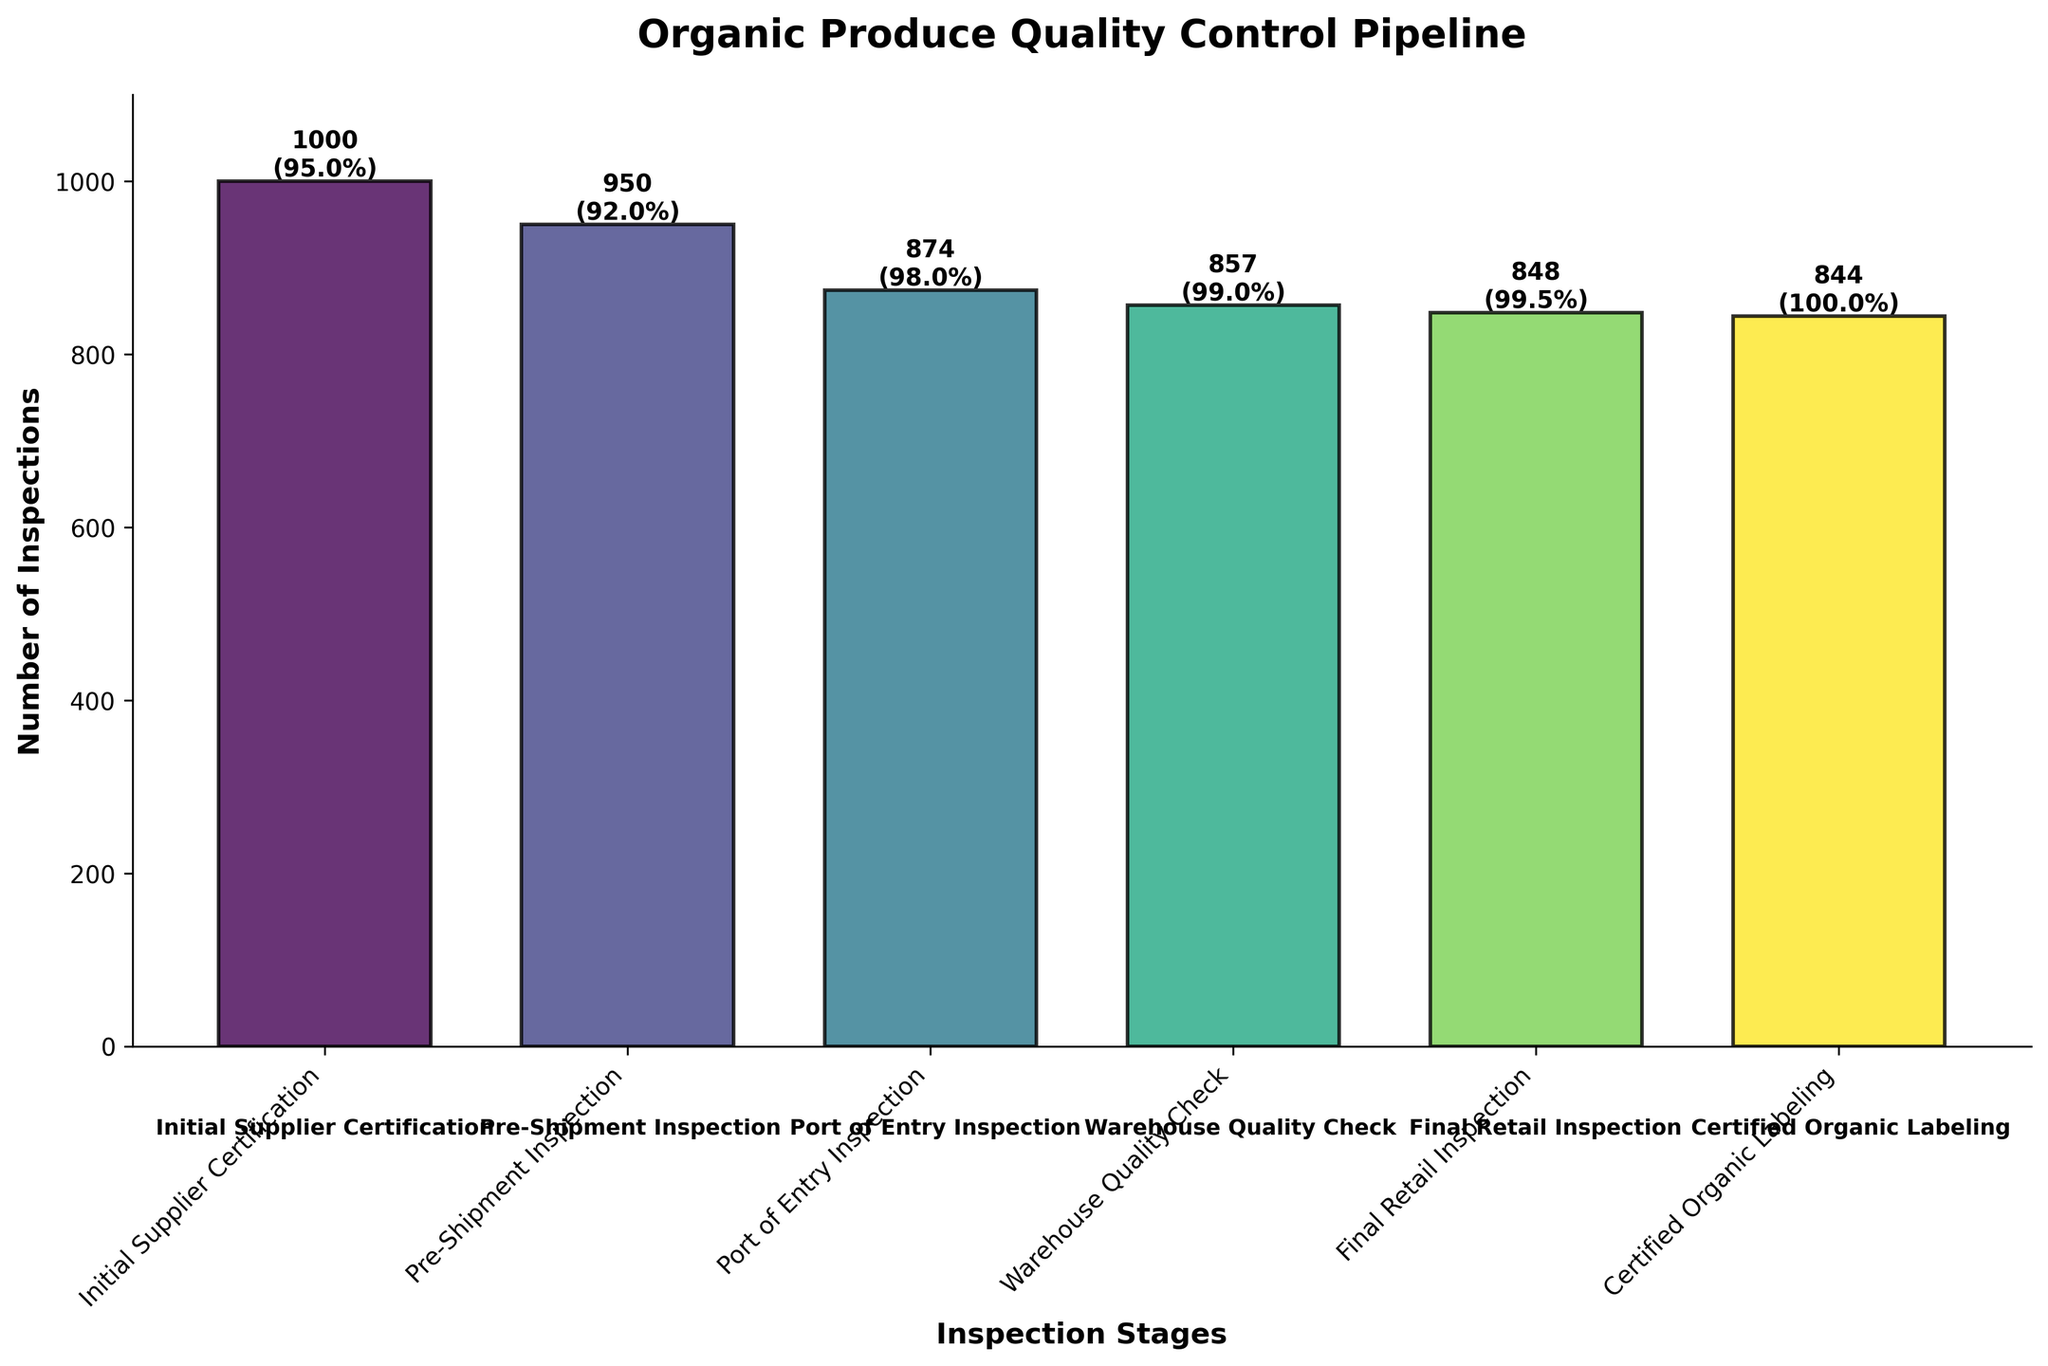What's the title of the figure? The title of the figure can be found at the top of the chart and it describes the overall content.
Answer: Organic Produce Quality Control Pipeline What stage occurs after the Pre-Shipment Inspection? To find the next stage after the Pre-Shipment Inspection, look at the sequence of stages from left to right in the chart.
Answer: Port of Entry Inspection How many inspections occur during the Warehouse Quality Check? The number from the Warehouse Quality Check is labeled directly on the bar.
Answer: 857 What is the pass rate at the Final Retail Inspection? The pass rate is labeled on the bar for Final Retail Inspection. Look for the percentage next to it.
Answer: 99.5% Which stage has the highest number of initial inspections? To find the highest number of initial inspections, look for the tallest bar in the chart.
Answer: Initial Supplier Certification How many fewer inspections are there at Certified Organic Labeling compared to Initial Supplier Certification? To find the difference, subtract the number of inspections at Certified Organic Labeling from the number at Initial Supplier Certification (1000 - 844).
Answer: 156 What is the pass rate increase from the Port of Entry Inspection to the Warehouse Quality Check? Subtract the pass rate at Port of Entry Inspection from the pass rate at Warehouse Quality Check (99% - 98%).
Answer: 1% Is the pass rate consistent between any consecutive stages? Compare the pass rates of consecutive stages to see if any are the same.
Answer: Yes, between Warehouse Quality Check and Final Retail Inspection both are at 99% How many stages have pass rates greater than 95%? Count the number of stages where the pass rate is greater than 95%.
Answer: 5 Which stage shows the largest drop in the number of inspections compared to the previous stage? Calculate the difference in inspections between each consecutive stage and identify the largest decrease. This occurs between Pre-Shipment Inspection and Port of Entry Inspection (950 - 874).
Answer: Pre-Shipment Inspection to Port of Entry Inspection 